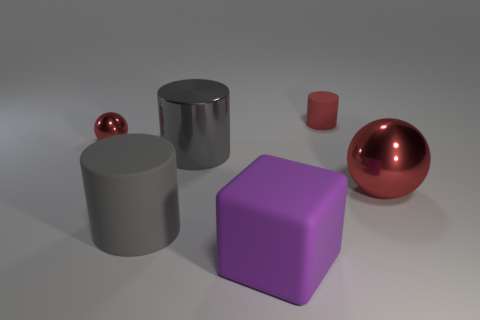Add 3 large gray matte cylinders. How many objects exist? 9 Subtract all cubes. How many objects are left? 5 Add 3 small red matte objects. How many small red matte objects exist? 4 Subtract 0 yellow spheres. How many objects are left? 6 Subtract all tiny rubber cylinders. Subtract all cubes. How many objects are left? 4 Add 3 large red balls. How many large red balls are left? 4 